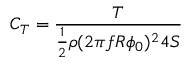<formula> <loc_0><loc_0><loc_500><loc_500>C _ { T } = \frac { T } { \frac { 1 } { 2 } \rho ( 2 \pi f R \phi _ { 0 } ) ^ { 2 } 4 S }</formula> 